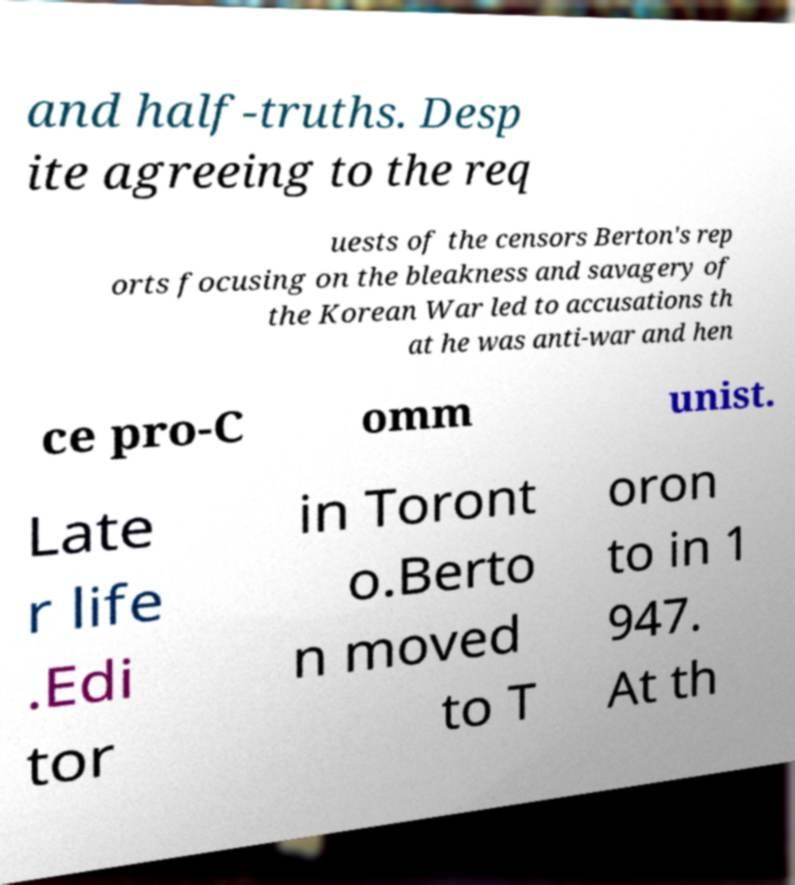I need the written content from this picture converted into text. Can you do that? and half-truths. Desp ite agreeing to the req uests of the censors Berton's rep orts focusing on the bleakness and savagery of the Korean War led to accusations th at he was anti-war and hen ce pro-C omm unist. Late r life .Edi tor in Toront o.Berto n moved to T oron to in 1 947. At th 